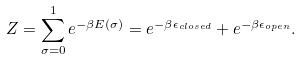<formula> <loc_0><loc_0><loc_500><loc_500>Z = \sum _ { \sigma = 0 } ^ { 1 } e ^ { - \beta E ( \sigma ) } = e ^ { - \beta \epsilon _ { c l o s e d } } + e ^ { - \beta \epsilon _ { o p e n } } .</formula> 